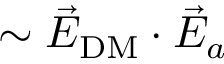<formula> <loc_0><loc_0><loc_500><loc_500>\sim \vec { E } _ { D M } \cdot \vec { E } _ { a }</formula> 